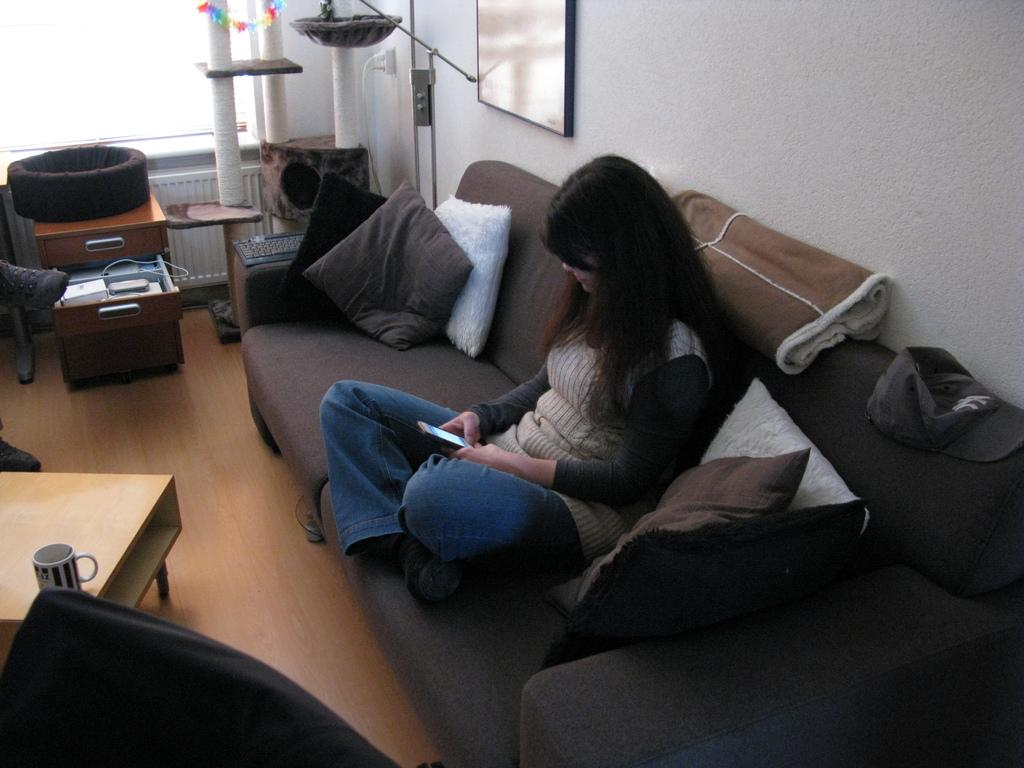What is the woman in the image doing? The woman is sitting on a couch in the image. What object can be seen on a table in the image? There is a cup on a table in the image. What is attached to the wall in the image? There is a frame attached to a wall in the image. What can be seen in the background of the image? There is a pole in the background of the image. How many beggars are visible in the image? There are no beggars present in the image. What type of knife is being used by the woman in the image? There is no knife visible in the image, and the woman is not using any knife. 